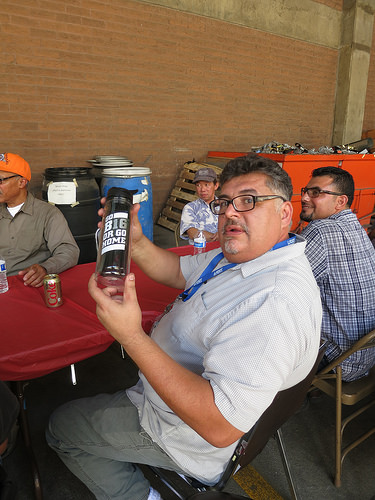<image>
Is there a can in the man? No. The can is not contained within the man. These objects have a different spatial relationship. 